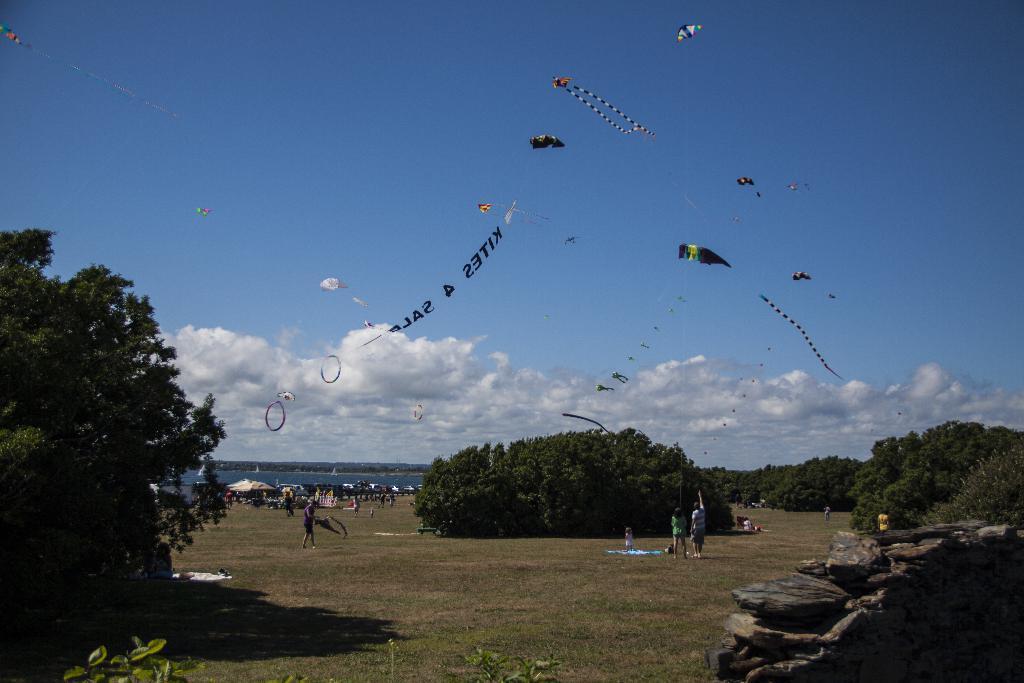Could you give a brief overview of what you see in this image? This image is clicked outside. There is sky at the top. There are trees in the middle. There are so many people in the middle who are flying kites. 